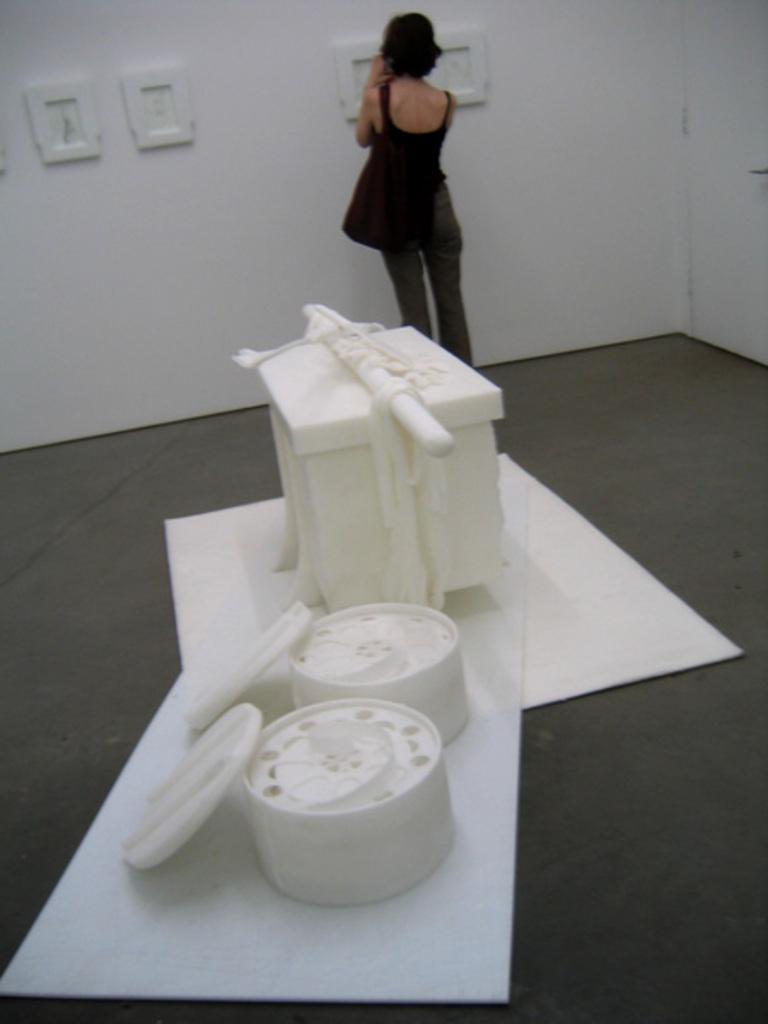Describe this image in one or two sentences. In this image, we can see white marble objects are placed on the surface. Here there is a floor. In the background, we can see a woman is standing and wearing bag. Here there is a wall and photo frames. 